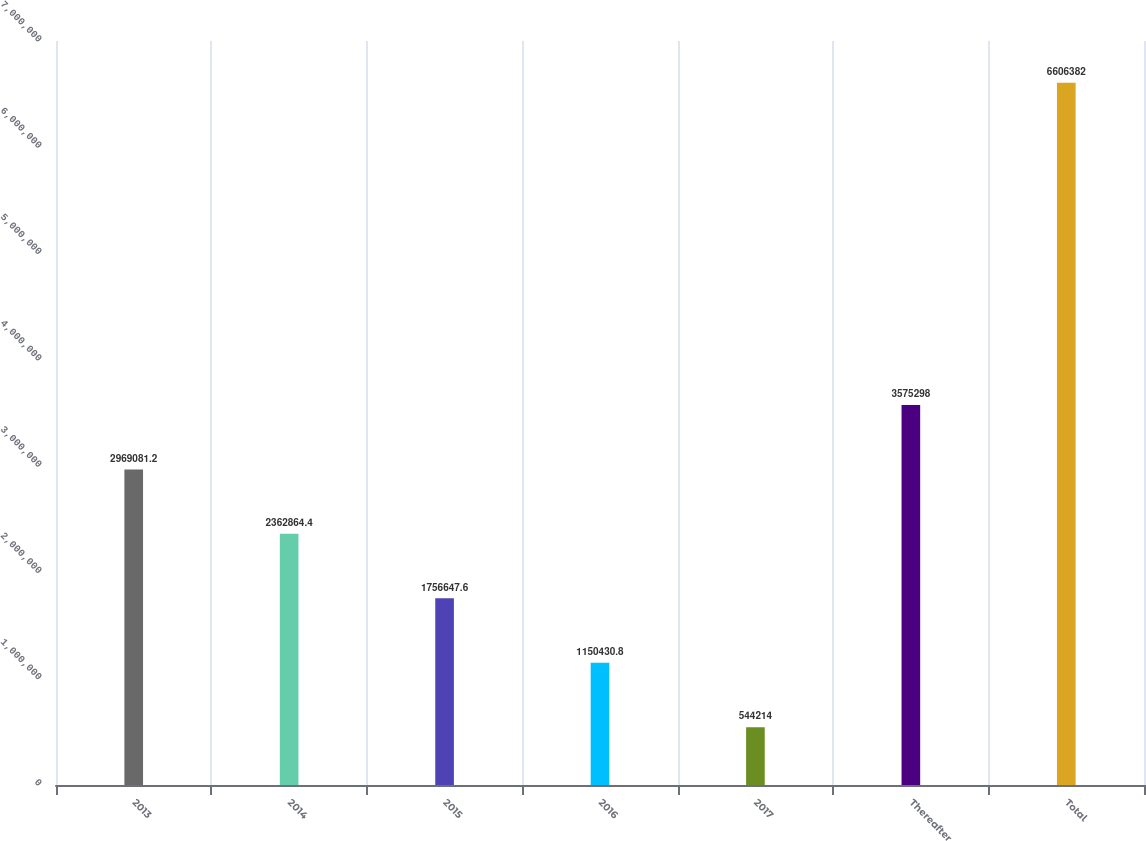Convert chart to OTSL. <chart><loc_0><loc_0><loc_500><loc_500><bar_chart><fcel>2013<fcel>2014<fcel>2015<fcel>2016<fcel>2017<fcel>Thereafter<fcel>Total<nl><fcel>2.96908e+06<fcel>2.36286e+06<fcel>1.75665e+06<fcel>1.15043e+06<fcel>544214<fcel>3.5753e+06<fcel>6.60638e+06<nl></chart> 